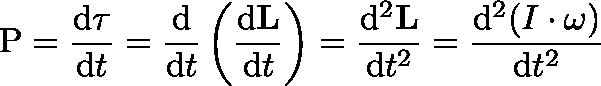<formula> <loc_0><loc_0><loc_500><loc_500>P = { \frac { d \tau } { d t } } = { \frac { d } { d t } } \left ( { \frac { d L } { d t } } \right ) = { \frac { d ^ { 2 } L } { d t ^ { 2 } } } = { \frac { d ^ { 2 } ( I \cdot \omega ) } { d t ^ { 2 } } }</formula> 